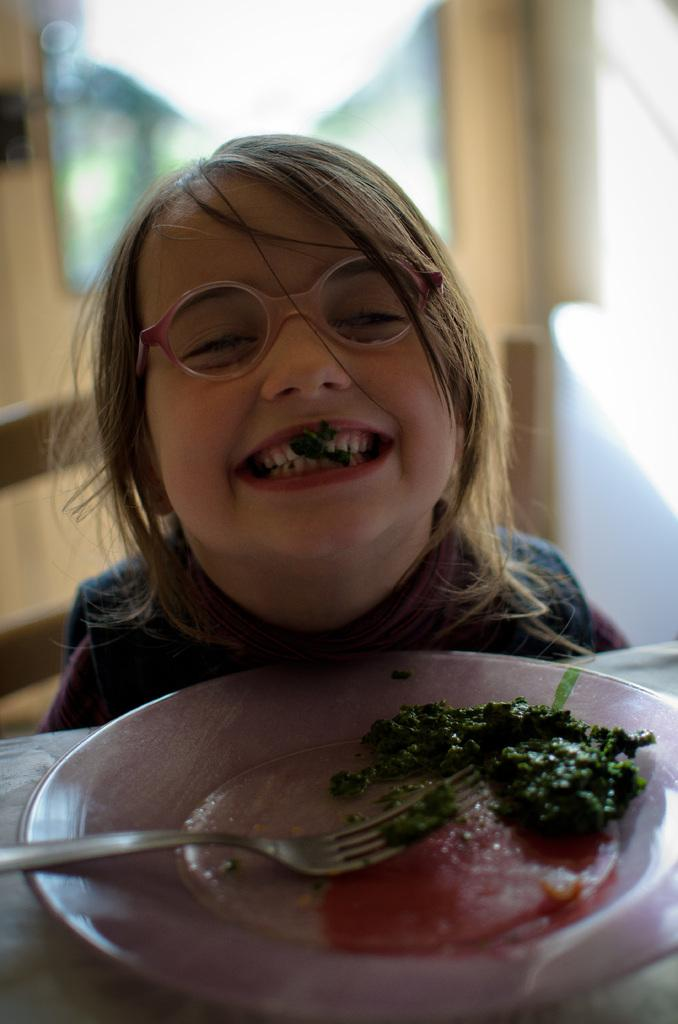What is the girl doing in the image? The girl is sitting and smiling in the image. What is on the table in front of the girl? The girl has a plate containing food in front of her. What utensil is placed on the table? A fork is placed on the table. What can be seen in the background of the image? There is a window and a wall in the background of the image. What type of island can be seen in the background of the image? There is no island present in the background of the image; it only shows a window and a wall. Is the girl sleeping in the image? No, the girl is sitting and smiling, not sleeping. 